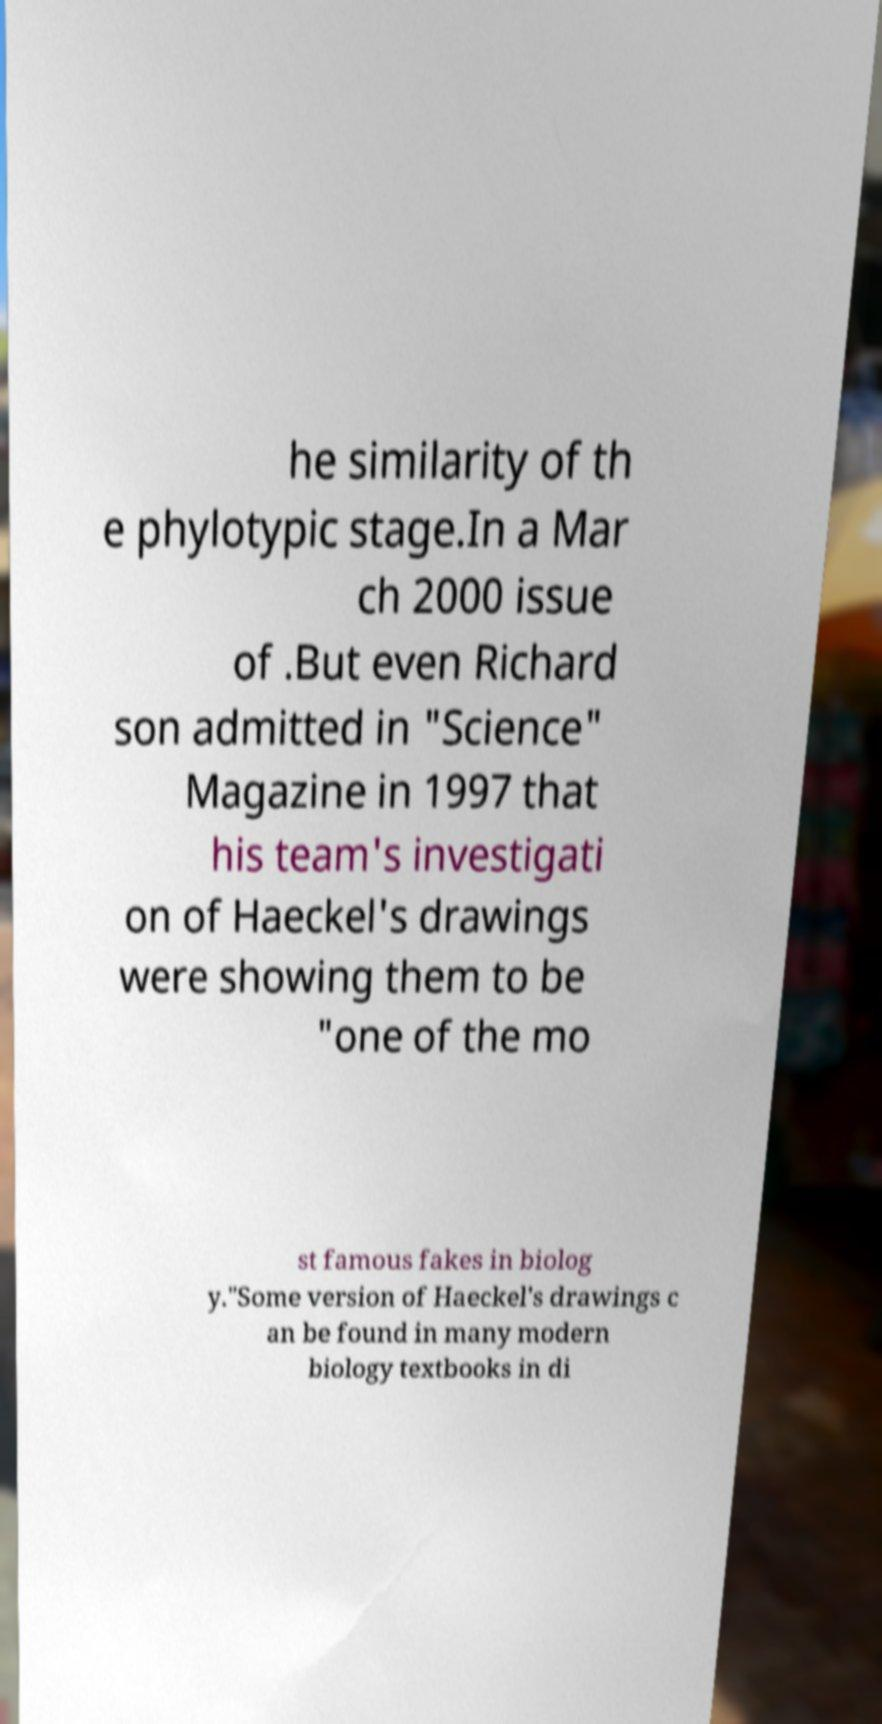Can you accurately transcribe the text from the provided image for me? he similarity of th e phylotypic stage.In a Mar ch 2000 issue of .But even Richard son admitted in "Science" Magazine in 1997 that his team's investigati on of Haeckel's drawings were showing them to be "one of the mo st famous fakes in biolog y."Some version of Haeckel's drawings c an be found in many modern biology textbooks in di 